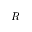<formula> <loc_0><loc_0><loc_500><loc_500>R</formula> 